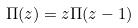<formula> <loc_0><loc_0><loc_500><loc_500>\Pi ( z ) = z \Pi ( z - 1 )</formula> 